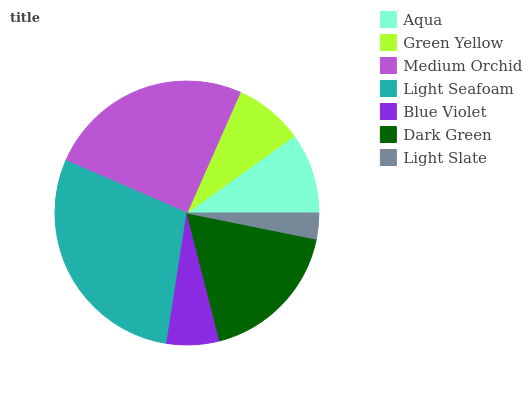Is Light Slate the minimum?
Answer yes or no. Yes. Is Light Seafoam the maximum?
Answer yes or no. Yes. Is Green Yellow the minimum?
Answer yes or no. No. Is Green Yellow the maximum?
Answer yes or no. No. Is Aqua greater than Green Yellow?
Answer yes or no. Yes. Is Green Yellow less than Aqua?
Answer yes or no. Yes. Is Green Yellow greater than Aqua?
Answer yes or no. No. Is Aqua less than Green Yellow?
Answer yes or no. No. Is Aqua the high median?
Answer yes or no. Yes. Is Aqua the low median?
Answer yes or no. Yes. Is Light Seafoam the high median?
Answer yes or no. No. Is Light Seafoam the low median?
Answer yes or no. No. 